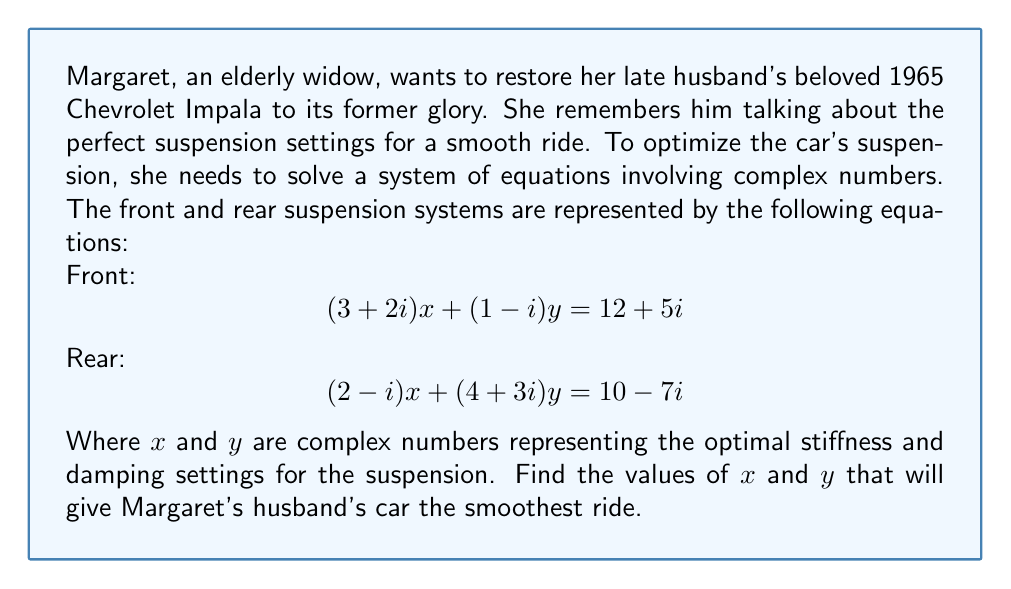Teach me how to tackle this problem. To solve this system of equations, we'll use the substitution method:

1) First, let's solve for $x$ in terms of $y$ using the first equation:
   $$(3+2i)x + (1-i)y = 12+5i$$
   $$(3+2i)x = (12+5i) - (1-i)y$$
   $$x = \frac{(12+5i) - (1-i)y}{3+2i}$$

2) Multiply both numerator and denominator by the complex conjugate of the denominator:
   $$x = \frac{((12+5i) - (1-i)y)(3-2i)}{(3+2i)(3-2i)}$$
   $$x = \frac{((12+5i) - (1-i)y)(3-2i)}{13}$$

3) Expand this expression:
   $$x = \frac{(36-24i+15i+10) - (3-2i-3i+2)y}{13}$$
   $$x = \frac{46-9i - (3-5i)y}{13}$$

4) Substitute this expression for $x$ into the second equation:
   $$(2-i)(\frac{46-9i - (3-5i)y}{13}) + (4+3i)y = 10-7i$$

5) Multiply both sides by 13:
   $$(2-i)(46-9i - (3-5i)y) + (52+39i)y = 130-91i$$

6) Expand:
   $$(92-18i-46i+9i^2) - (6-10i-3i+5i^2)y + (52+39i)y = 130-91i$$
   $$(92-18i-46i-9) - (6-13i+5)y + (52+39i)y = 130-91i$$
   $$83-64i - (6-13i+5)y + (52+39i)y = 130-91i$$
   $$83-64i + (46+52i)y = 130-91i$$

7) Equate real and imaginary parts:
   Real: $$83 + 46\text{Re}(y) - 52\text{Im}(y) = 130$$
   Imaginary: $$-64 + 52\text{Re}(y) + 46\text{Im}(y) = -91$$

8) Solve this system of linear equations:
   $$46\text{Re}(y) - 52\text{Im}(y) = 47$$
   $$52\text{Re}(y) + 46\text{Im}(y) = -27$$

9) Using elimination method:
   Multiply the first equation by 52 and the second by 46:
   $$2392\text{Re}(y) - 2704\text{Im}(y) = 2444$$
   $$2392\text{Re}(y) + 2116\text{Im}(y) = -1242$$

   Subtract the second equation from the first:
   $$-4820\text{Im}(y) = 3686$$
   $$\text{Im}(y) = -\frac{3686}{4820} = -0.765$$

10) Substitute this value back into one of the equations from step 8:
    $$46\text{Re}(y) - 52(-0.765) = 47$$
    $$46\text{Re}(y) = 47 - 39.78 = 7.22$$
    $$\text{Re}(y) = 0.157$$

11) Therefore, $y = 0.157 - 0.765i$

12) Substitute this value of $y$ back into the expression for $x$ from step 3:
    $$x = \frac{46-9i - (3-5i)(0.157 - 0.765i)}{13}$$
    $$x = \frac{46-9i - (0.471 + 2.295i + 0.785i - 3.825)}{13}$$
    $$x = \frac{49.354 - 12.08i}{13}$$
    $$x = 3.797 - 0.929i$$
Answer: $x = 3.797 - 0.929i$ and $y = 0.157 - 0.765i$ 